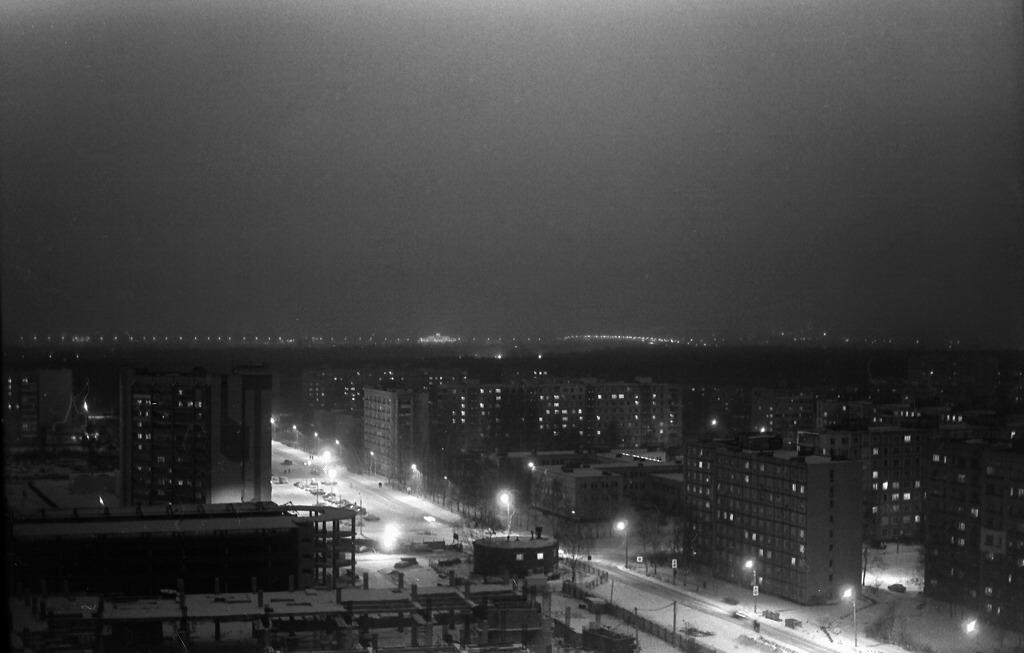What type of structures can be seen in the image? There are buildings in the image. What type of lighting is present in the image? There are streetlights in the image. What can be seen in the background of the image? The sky is visible in the background of the image. Can you see the smile on the ball in the image? There is no ball or smile present in the image. 